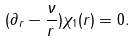<formula> <loc_0><loc_0><loc_500><loc_500>( \partial _ { r } - \frac { \nu } { r } ) \chi _ { 1 } ( r ) = 0 .</formula> 